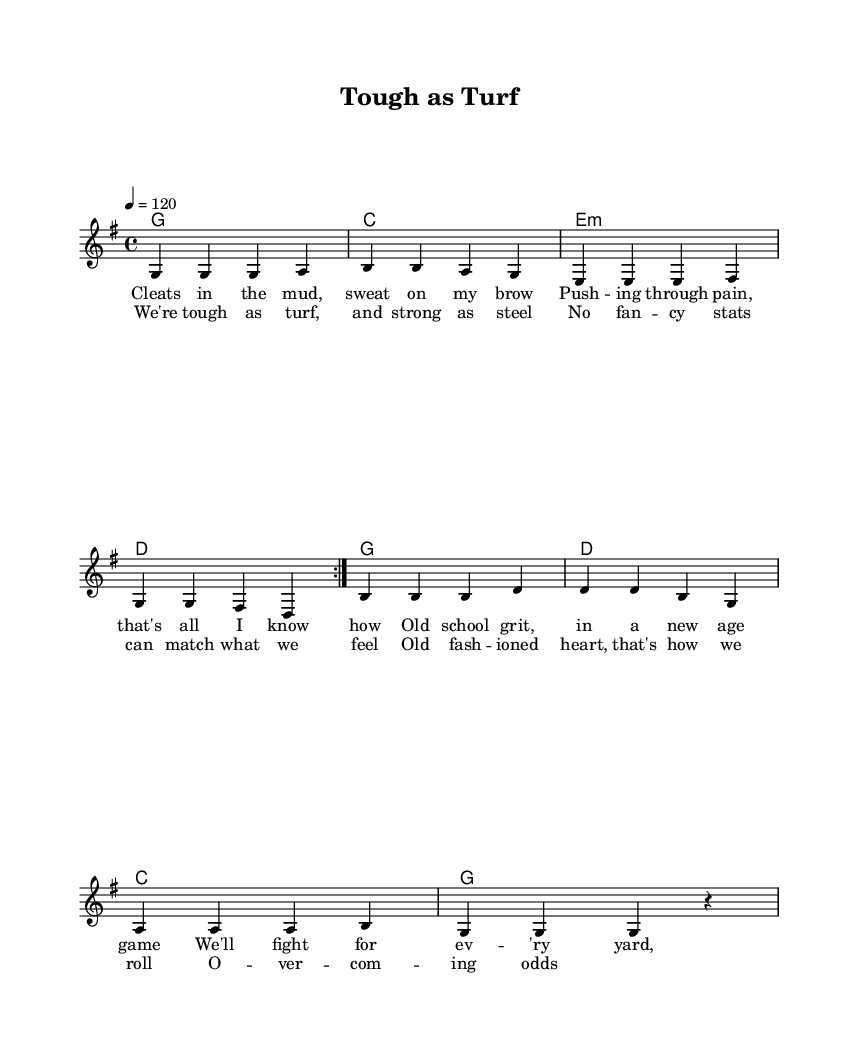What is the key signature of this music? The key signature is indicated at the beginning of the sheet music, showing one sharp on the F line, which means it is G major.
Answer: G major What is the time signature of this music? The time signature appears next to the key signature and indicates that there are four beats in each measure, denoted as 4/4.
Answer: 4/4 What is the tempo marking for this piece? The tempo marking is found at the beginning of the sheet music, stating 4 equals 120, which means the music should be played at a speed of 120 beats per minute.
Answer: 120 How many measures are in the chorus? The chorus consists of one section labeled as a repeated stanza, which has four measures based on the layout of the melody and lyrics.
Answer: Four measures What is the primary theme of the lyrics in the verse? The lyrics describe perseverance and traditional grit in the face of adversity, particularly relating to sports and hard work, creating a consistent theme of overcoming challenges.
Answer: Perseverance In which section of the music do we see the lyrics "We're tough as turf, and strong as steel"? This line is part of the chorus, which follows after the first verse, indicating a shift in the focus of the song to a more uplifting declaration of strength.
Answer: Chorus 